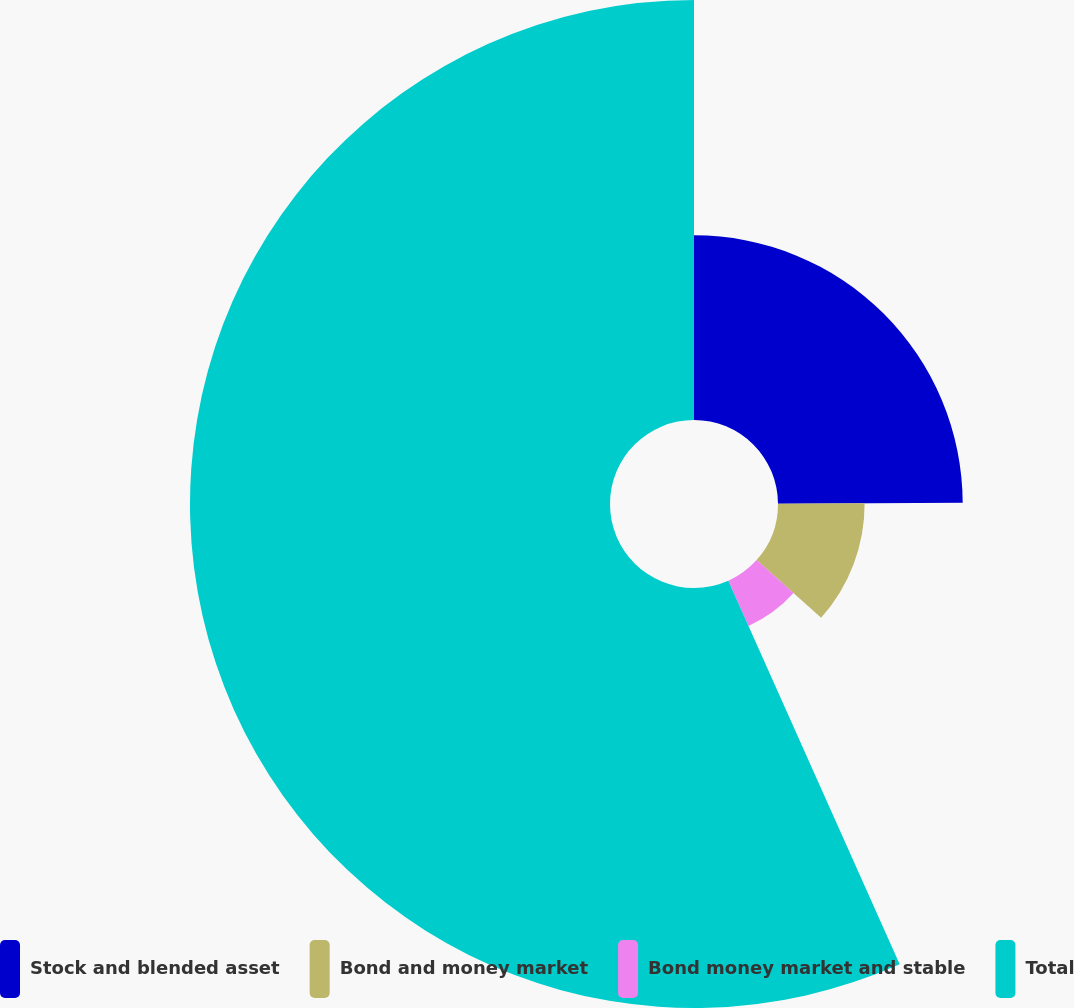Convert chart to OTSL. <chart><loc_0><loc_0><loc_500><loc_500><pie_chart><fcel>Stock and blended asset<fcel>Bond and money market<fcel>Bond money market and stable<fcel>Total<nl><fcel>24.93%<fcel>11.69%<fcel>6.69%<fcel>56.69%<nl></chart> 